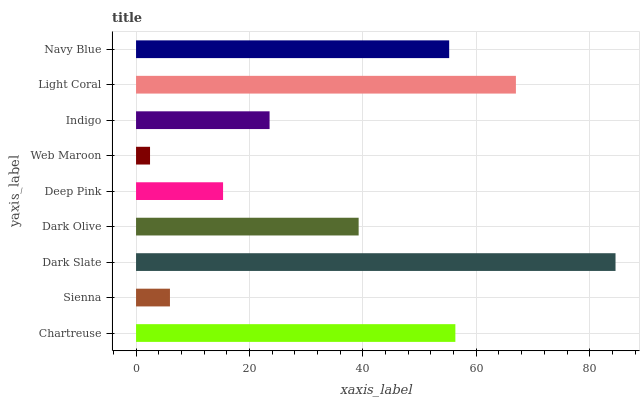Is Web Maroon the minimum?
Answer yes or no. Yes. Is Dark Slate the maximum?
Answer yes or no. Yes. Is Sienna the minimum?
Answer yes or no. No. Is Sienna the maximum?
Answer yes or no. No. Is Chartreuse greater than Sienna?
Answer yes or no. Yes. Is Sienna less than Chartreuse?
Answer yes or no. Yes. Is Sienna greater than Chartreuse?
Answer yes or no. No. Is Chartreuse less than Sienna?
Answer yes or no. No. Is Dark Olive the high median?
Answer yes or no. Yes. Is Dark Olive the low median?
Answer yes or no. Yes. Is Indigo the high median?
Answer yes or no. No. Is Sienna the low median?
Answer yes or no. No. 